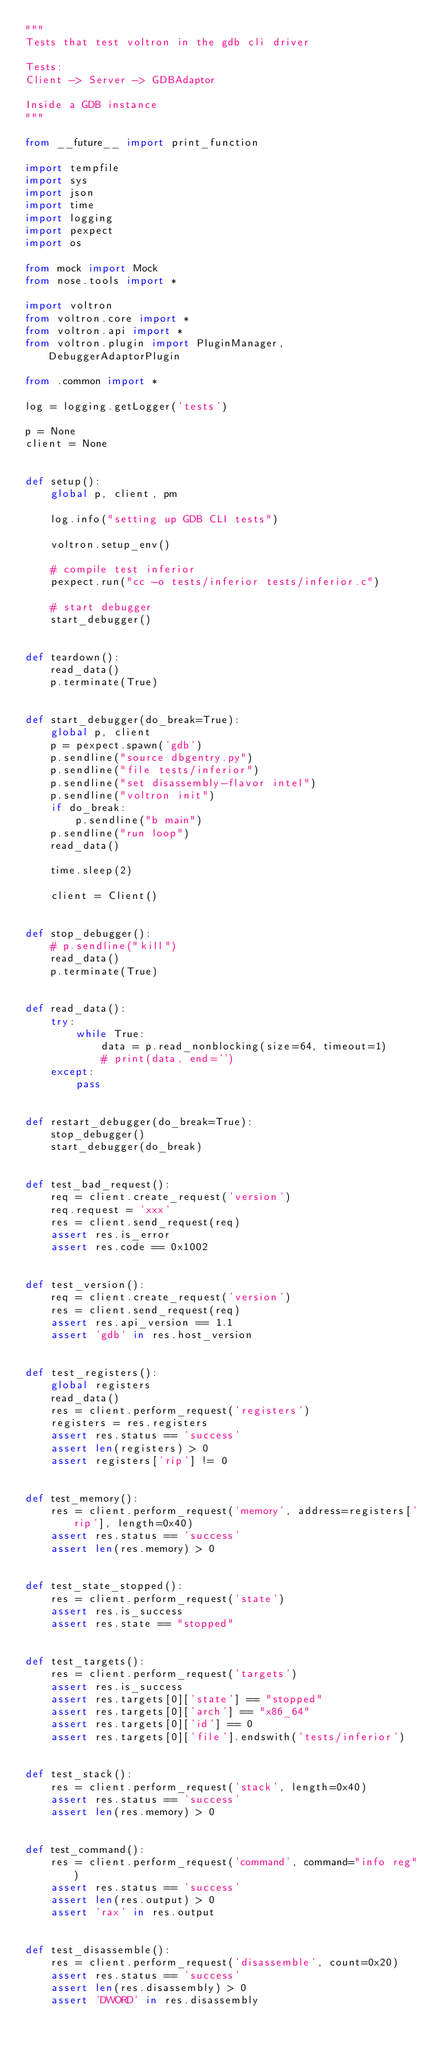Convert code to text. <code><loc_0><loc_0><loc_500><loc_500><_Python_>"""
Tests that test voltron in the gdb cli driver

Tests:
Client -> Server -> GDBAdaptor

Inside a GDB instance
"""

from __future__ import print_function

import tempfile
import sys
import json
import time
import logging
import pexpect
import os

from mock import Mock
from nose.tools import *

import voltron
from voltron.core import *
from voltron.api import *
from voltron.plugin import PluginManager, DebuggerAdaptorPlugin

from .common import *

log = logging.getLogger('tests')

p = None
client = None


def setup():
    global p, client, pm

    log.info("setting up GDB CLI tests")

    voltron.setup_env()

    # compile test inferior
    pexpect.run("cc -o tests/inferior tests/inferior.c")

    # start debugger
    start_debugger()


def teardown():
    read_data()
    p.terminate(True)


def start_debugger(do_break=True):
    global p, client
    p = pexpect.spawn('gdb')
    p.sendline("source dbgentry.py")
    p.sendline("file tests/inferior")
    p.sendline("set disassembly-flavor intel")
    p.sendline("voltron init")
    if do_break:
        p.sendline("b main")
    p.sendline("run loop")
    read_data()

    time.sleep(2)

    client = Client()


def stop_debugger():
    # p.sendline("kill")
    read_data()
    p.terminate(True)


def read_data():
    try:
        while True:
            data = p.read_nonblocking(size=64, timeout=1)
            # print(data, end='')
    except:
        pass


def restart_debugger(do_break=True):
    stop_debugger()
    start_debugger(do_break)


def test_bad_request():
    req = client.create_request('version')
    req.request = 'xxx'
    res = client.send_request(req)
    assert res.is_error
    assert res.code == 0x1002


def test_version():
    req = client.create_request('version')
    res = client.send_request(req)
    assert res.api_version == 1.1
    assert 'gdb' in res.host_version


def test_registers():
    global registers
    read_data()
    res = client.perform_request('registers')
    registers = res.registers
    assert res.status == 'success'
    assert len(registers) > 0
    assert registers['rip'] != 0


def test_memory():
    res = client.perform_request('memory', address=registers['rip'], length=0x40)
    assert res.status == 'success'
    assert len(res.memory) > 0


def test_state_stopped():
    res = client.perform_request('state')
    assert res.is_success
    assert res.state == "stopped"


def test_targets():
    res = client.perform_request('targets')
    assert res.is_success
    assert res.targets[0]['state'] == "stopped"
    assert res.targets[0]['arch'] == "x86_64"
    assert res.targets[0]['id'] == 0
    assert res.targets[0]['file'].endswith('tests/inferior')


def test_stack():
    res = client.perform_request('stack', length=0x40)
    assert res.status == 'success'
    assert len(res.memory) > 0


def test_command():
    res = client.perform_request('command', command="info reg")
    assert res.status == 'success'
    assert len(res.output) > 0
    assert 'rax' in res.output


def test_disassemble():
    res = client.perform_request('disassemble', count=0x20)
    assert res.status == 'success'
    assert len(res.disassembly) > 0
    assert 'DWORD' in res.disassembly
</code> 